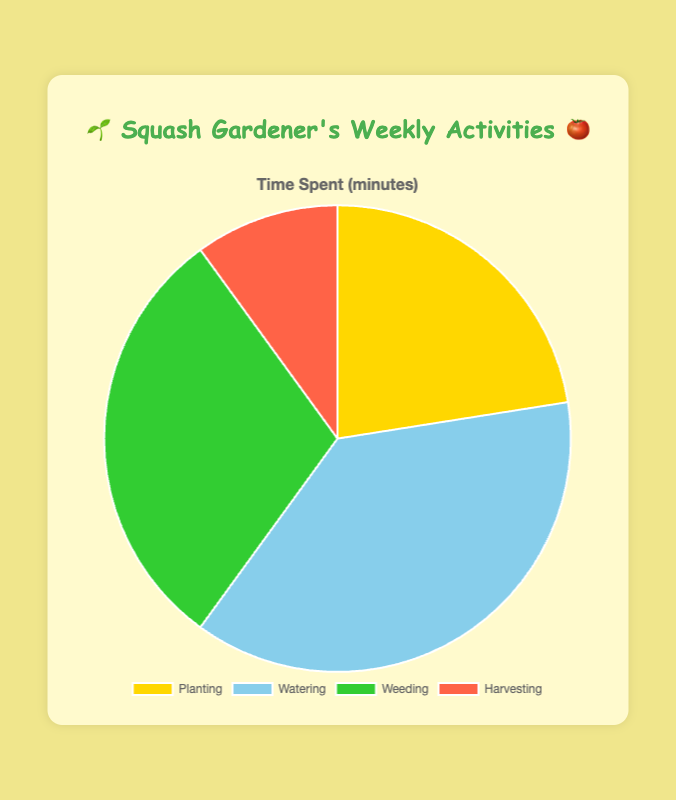What activity takes up the most time? By looking at the chart, it's clear that the largest section represents "Watering," which means it must take the most time.
Answer: Watering How much total time is spent on activities other than watering? Add the time spent on Planting, Weeding, and Harvesting: 180 + 240 + 80 = 500 minutes.
Answer: 500 minutes Which activity takes half the time of watering? Compare the time spent on each activity to watering's 300 minutes. Weeding takes 240 minutes, which is closest but only a potential half-time activity would be: 300 / 2 = 150 minutes, which none of the given sections seem to accurately match. This makes none of the activities exactly half of watering but Weeding is significantly less.
Answer: None By how much does the time spent on weeding exceed the time spent on harvesting? Subtract the time for harvesting from the time for weeding: 240 - 80 = 160 minutes.
Answer: 160 minutes Rank the activities from the least to the most time spent. The chart sections can help rank them as follows: Harvesting (80 minutes), Planting (180 minutes), Weeding (240 minutes), and Watering (300 minutes).
Answer: Harvesting, Planting, Weeding, Watering What percentage of the total time is spent on planting? First find the total time: 180 + 300 + 240 + 80 = 800 minutes. Then calculate the percentage for planting: (180 / 800) * 100 = 22.5%.
Answer: 22.5% How much more time is dedicated to watering compared to planting and harvesting combined? First find the combined time for planting and harvesting: 180 + 80 = 260 minutes. Then find the difference between watering and this total: 300 - 260 = 40 minutes.
Answer: 40 minutes Which activity has a yellow section in the chart? By looking at the chart's color coding, the yellow section represents "Planting."
Answer: Planting If you were to do planting and harvesting back-to-back, how many hours would that take? First sum the time spent on planting and harvesting: 180 + 80 = 260 minutes. Then convert this total into hours: 260 / 60 ≈ 4.33 hours.
Answer: 4.33 hours 